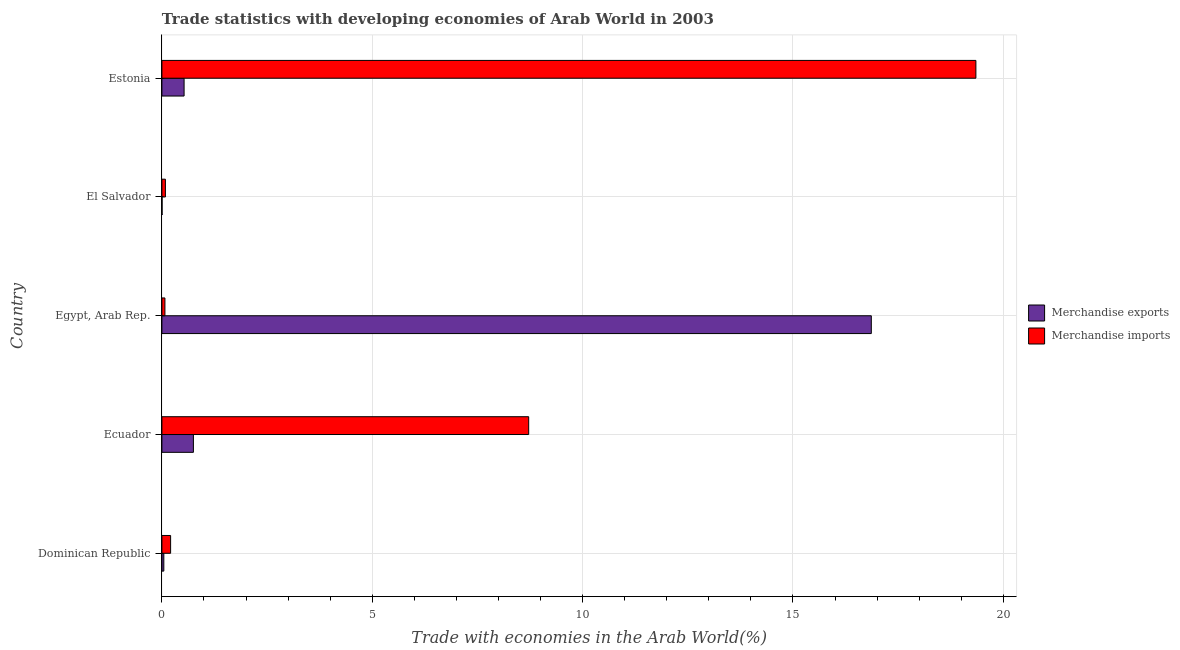How many different coloured bars are there?
Make the answer very short. 2. Are the number of bars per tick equal to the number of legend labels?
Offer a very short reply. Yes. How many bars are there on the 2nd tick from the top?
Provide a succinct answer. 2. What is the label of the 4th group of bars from the top?
Make the answer very short. Ecuador. What is the merchandise imports in El Salvador?
Provide a short and direct response. 0.08. Across all countries, what is the maximum merchandise exports?
Offer a very short reply. 16.86. Across all countries, what is the minimum merchandise exports?
Give a very brief answer. 0. In which country was the merchandise imports maximum?
Offer a terse response. Estonia. In which country was the merchandise exports minimum?
Ensure brevity in your answer.  El Salvador. What is the total merchandise imports in the graph?
Provide a short and direct response. 28.43. What is the difference between the merchandise imports in Dominican Republic and that in Estonia?
Offer a terse response. -19.14. What is the difference between the merchandise exports in Ecuador and the merchandise imports in Egypt, Arab Rep.?
Your response must be concise. 0.68. What is the average merchandise imports per country?
Your answer should be compact. 5.69. What is the difference between the merchandise exports and merchandise imports in Ecuador?
Your response must be concise. -7.97. In how many countries, is the merchandise exports greater than 14 %?
Your answer should be compact. 1. What is the ratio of the merchandise imports in Ecuador to that in Estonia?
Provide a succinct answer. 0.45. Is the merchandise imports in Egypt, Arab Rep. less than that in El Salvador?
Give a very brief answer. Yes. Is the difference between the merchandise exports in Ecuador and El Salvador greater than the difference between the merchandise imports in Ecuador and El Salvador?
Your response must be concise. No. What is the difference between the highest and the second highest merchandise exports?
Keep it short and to the point. 16.11. What is the difference between the highest and the lowest merchandise imports?
Ensure brevity in your answer.  19.28. In how many countries, is the merchandise exports greater than the average merchandise exports taken over all countries?
Provide a short and direct response. 1. Is the sum of the merchandise imports in Dominican Republic and Estonia greater than the maximum merchandise exports across all countries?
Your answer should be compact. Yes. How many bars are there?
Keep it short and to the point. 10. Are all the bars in the graph horizontal?
Keep it short and to the point. Yes. Are the values on the major ticks of X-axis written in scientific E-notation?
Your response must be concise. No. Where does the legend appear in the graph?
Ensure brevity in your answer.  Center right. How are the legend labels stacked?
Offer a very short reply. Vertical. What is the title of the graph?
Provide a short and direct response. Trade statistics with developing economies of Arab World in 2003. Does "RDB concessional" appear as one of the legend labels in the graph?
Ensure brevity in your answer.  No. What is the label or title of the X-axis?
Keep it short and to the point. Trade with economies in the Arab World(%). What is the label or title of the Y-axis?
Offer a terse response. Country. What is the Trade with economies in the Arab World(%) in Merchandise exports in Dominican Republic?
Provide a short and direct response. 0.05. What is the Trade with economies in the Arab World(%) in Merchandise imports in Dominican Republic?
Offer a very short reply. 0.21. What is the Trade with economies in the Arab World(%) of Merchandise exports in Ecuador?
Keep it short and to the point. 0.75. What is the Trade with economies in the Arab World(%) of Merchandise imports in Ecuador?
Provide a short and direct response. 8.72. What is the Trade with economies in the Arab World(%) in Merchandise exports in Egypt, Arab Rep.?
Your answer should be compact. 16.86. What is the Trade with economies in the Arab World(%) in Merchandise imports in Egypt, Arab Rep.?
Your response must be concise. 0.07. What is the Trade with economies in the Arab World(%) of Merchandise exports in El Salvador?
Offer a terse response. 0. What is the Trade with economies in the Arab World(%) in Merchandise imports in El Salvador?
Offer a terse response. 0.08. What is the Trade with economies in the Arab World(%) in Merchandise exports in Estonia?
Offer a terse response. 0.53. What is the Trade with economies in the Arab World(%) of Merchandise imports in Estonia?
Offer a terse response. 19.35. Across all countries, what is the maximum Trade with economies in the Arab World(%) of Merchandise exports?
Make the answer very short. 16.86. Across all countries, what is the maximum Trade with economies in the Arab World(%) of Merchandise imports?
Ensure brevity in your answer.  19.35. Across all countries, what is the minimum Trade with economies in the Arab World(%) of Merchandise exports?
Offer a terse response. 0. Across all countries, what is the minimum Trade with economies in the Arab World(%) of Merchandise imports?
Provide a succinct answer. 0.07. What is the total Trade with economies in the Arab World(%) of Merchandise exports in the graph?
Ensure brevity in your answer.  18.19. What is the total Trade with economies in the Arab World(%) in Merchandise imports in the graph?
Your answer should be compact. 28.43. What is the difference between the Trade with economies in the Arab World(%) of Merchandise exports in Dominican Republic and that in Ecuador?
Offer a terse response. -0.7. What is the difference between the Trade with economies in the Arab World(%) in Merchandise imports in Dominican Republic and that in Ecuador?
Keep it short and to the point. -8.51. What is the difference between the Trade with economies in the Arab World(%) in Merchandise exports in Dominican Republic and that in Egypt, Arab Rep.?
Your answer should be compact. -16.82. What is the difference between the Trade with economies in the Arab World(%) in Merchandise imports in Dominican Republic and that in Egypt, Arab Rep.?
Provide a succinct answer. 0.14. What is the difference between the Trade with economies in the Arab World(%) in Merchandise exports in Dominican Republic and that in El Salvador?
Your response must be concise. 0.04. What is the difference between the Trade with economies in the Arab World(%) in Merchandise imports in Dominican Republic and that in El Salvador?
Your answer should be compact. 0.12. What is the difference between the Trade with economies in the Arab World(%) in Merchandise exports in Dominican Republic and that in Estonia?
Your answer should be very brief. -0.48. What is the difference between the Trade with economies in the Arab World(%) of Merchandise imports in Dominican Republic and that in Estonia?
Provide a short and direct response. -19.14. What is the difference between the Trade with economies in the Arab World(%) in Merchandise exports in Ecuador and that in Egypt, Arab Rep.?
Your response must be concise. -16.11. What is the difference between the Trade with economies in the Arab World(%) of Merchandise imports in Ecuador and that in Egypt, Arab Rep.?
Make the answer very short. 8.65. What is the difference between the Trade with economies in the Arab World(%) of Merchandise exports in Ecuador and that in El Salvador?
Your answer should be very brief. 0.74. What is the difference between the Trade with economies in the Arab World(%) of Merchandise imports in Ecuador and that in El Salvador?
Ensure brevity in your answer.  8.64. What is the difference between the Trade with economies in the Arab World(%) of Merchandise exports in Ecuador and that in Estonia?
Ensure brevity in your answer.  0.22. What is the difference between the Trade with economies in the Arab World(%) in Merchandise imports in Ecuador and that in Estonia?
Offer a terse response. -10.63. What is the difference between the Trade with economies in the Arab World(%) in Merchandise exports in Egypt, Arab Rep. and that in El Salvador?
Make the answer very short. 16.86. What is the difference between the Trade with economies in the Arab World(%) in Merchandise imports in Egypt, Arab Rep. and that in El Salvador?
Give a very brief answer. -0.01. What is the difference between the Trade with economies in the Arab World(%) of Merchandise exports in Egypt, Arab Rep. and that in Estonia?
Provide a short and direct response. 16.34. What is the difference between the Trade with economies in the Arab World(%) of Merchandise imports in Egypt, Arab Rep. and that in Estonia?
Provide a short and direct response. -19.28. What is the difference between the Trade with economies in the Arab World(%) of Merchandise exports in El Salvador and that in Estonia?
Offer a very short reply. -0.52. What is the difference between the Trade with economies in the Arab World(%) of Merchandise imports in El Salvador and that in Estonia?
Your answer should be compact. -19.27. What is the difference between the Trade with economies in the Arab World(%) in Merchandise exports in Dominican Republic and the Trade with economies in the Arab World(%) in Merchandise imports in Ecuador?
Your answer should be compact. -8.67. What is the difference between the Trade with economies in the Arab World(%) of Merchandise exports in Dominican Republic and the Trade with economies in the Arab World(%) of Merchandise imports in Egypt, Arab Rep.?
Your answer should be compact. -0.03. What is the difference between the Trade with economies in the Arab World(%) of Merchandise exports in Dominican Republic and the Trade with economies in the Arab World(%) of Merchandise imports in El Salvador?
Make the answer very short. -0.04. What is the difference between the Trade with economies in the Arab World(%) of Merchandise exports in Dominican Republic and the Trade with economies in the Arab World(%) of Merchandise imports in Estonia?
Make the answer very short. -19.3. What is the difference between the Trade with economies in the Arab World(%) of Merchandise exports in Ecuador and the Trade with economies in the Arab World(%) of Merchandise imports in Egypt, Arab Rep.?
Keep it short and to the point. 0.68. What is the difference between the Trade with economies in the Arab World(%) in Merchandise exports in Ecuador and the Trade with economies in the Arab World(%) in Merchandise imports in El Salvador?
Provide a succinct answer. 0.67. What is the difference between the Trade with economies in the Arab World(%) in Merchandise exports in Ecuador and the Trade with economies in the Arab World(%) in Merchandise imports in Estonia?
Your answer should be very brief. -18.6. What is the difference between the Trade with economies in the Arab World(%) in Merchandise exports in Egypt, Arab Rep. and the Trade with economies in the Arab World(%) in Merchandise imports in El Salvador?
Your answer should be very brief. 16.78. What is the difference between the Trade with economies in the Arab World(%) in Merchandise exports in Egypt, Arab Rep. and the Trade with economies in the Arab World(%) in Merchandise imports in Estonia?
Ensure brevity in your answer.  -2.49. What is the difference between the Trade with economies in the Arab World(%) in Merchandise exports in El Salvador and the Trade with economies in the Arab World(%) in Merchandise imports in Estonia?
Give a very brief answer. -19.34. What is the average Trade with economies in the Arab World(%) of Merchandise exports per country?
Ensure brevity in your answer.  3.64. What is the average Trade with economies in the Arab World(%) of Merchandise imports per country?
Provide a short and direct response. 5.69. What is the difference between the Trade with economies in the Arab World(%) in Merchandise exports and Trade with economies in the Arab World(%) in Merchandise imports in Dominican Republic?
Give a very brief answer. -0.16. What is the difference between the Trade with economies in the Arab World(%) of Merchandise exports and Trade with economies in the Arab World(%) of Merchandise imports in Ecuador?
Your answer should be compact. -7.97. What is the difference between the Trade with economies in the Arab World(%) of Merchandise exports and Trade with economies in the Arab World(%) of Merchandise imports in Egypt, Arab Rep.?
Your response must be concise. 16.79. What is the difference between the Trade with economies in the Arab World(%) of Merchandise exports and Trade with economies in the Arab World(%) of Merchandise imports in El Salvador?
Provide a short and direct response. -0.08. What is the difference between the Trade with economies in the Arab World(%) in Merchandise exports and Trade with economies in the Arab World(%) in Merchandise imports in Estonia?
Provide a short and direct response. -18.82. What is the ratio of the Trade with economies in the Arab World(%) of Merchandise exports in Dominican Republic to that in Ecuador?
Offer a terse response. 0.06. What is the ratio of the Trade with economies in the Arab World(%) in Merchandise imports in Dominican Republic to that in Ecuador?
Your response must be concise. 0.02. What is the ratio of the Trade with economies in the Arab World(%) in Merchandise exports in Dominican Republic to that in Egypt, Arab Rep.?
Your answer should be very brief. 0. What is the ratio of the Trade with economies in the Arab World(%) in Merchandise imports in Dominican Republic to that in Egypt, Arab Rep.?
Make the answer very short. 2.89. What is the ratio of the Trade with economies in the Arab World(%) of Merchandise exports in Dominican Republic to that in El Salvador?
Offer a terse response. 12.49. What is the ratio of the Trade with economies in the Arab World(%) in Merchandise imports in Dominican Republic to that in El Salvador?
Ensure brevity in your answer.  2.49. What is the ratio of the Trade with economies in the Arab World(%) in Merchandise exports in Dominican Republic to that in Estonia?
Your response must be concise. 0.09. What is the ratio of the Trade with economies in the Arab World(%) in Merchandise imports in Dominican Republic to that in Estonia?
Your response must be concise. 0.01. What is the ratio of the Trade with economies in the Arab World(%) of Merchandise exports in Ecuador to that in Egypt, Arab Rep.?
Your response must be concise. 0.04. What is the ratio of the Trade with economies in the Arab World(%) in Merchandise imports in Ecuador to that in Egypt, Arab Rep.?
Your response must be concise. 121.68. What is the ratio of the Trade with economies in the Arab World(%) in Merchandise exports in Ecuador to that in El Salvador?
Provide a succinct answer. 204.11. What is the ratio of the Trade with economies in the Arab World(%) in Merchandise imports in Ecuador to that in El Salvador?
Make the answer very short. 104.76. What is the ratio of the Trade with economies in the Arab World(%) of Merchandise exports in Ecuador to that in Estonia?
Provide a short and direct response. 1.42. What is the ratio of the Trade with economies in the Arab World(%) in Merchandise imports in Ecuador to that in Estonia?
Give a very brief answer. 0.45. What is the ratio of the Trade with economies in the Arab World(%) of Merchandise exports in Egypt, Arab Rep. to that in El Salvador?
Keep it short and to the point. 4596.99. What is the ratio of the Trade with economies in the Arab World(%) of Merchandise imports in Egypt, Arab Rep. to that in El Salvador?
Your answer should be very brief. 0.86. What is the ratio of the Trade with economies in the Arab World(%) of Merchandise exports in Egypt, Arab Rep. to that in Estonia?
Offer a terse response. 31.98. What is the ratio of the Trade with economies in the Arab World(%) in Merchandise imports in Egypt, Arab Rep. to that in Estonia?
Provide a short and direct response. 0. What is the ratio of the Trade with economies in the Arab World(%) of Merchandise exports in El Salvador to that in Estonia?
Ensure brevity in your answer.  0.01. What is the ratio of the Trade with economies in the Arab World(%) in Merchandise imports in El Salvador to that in Estonia?
Your response must be concise. 0. What is the difference between the highest and the second highest Trade with economies in the Arab World(%) of Merchandise exports?
Your answer should be very brief. 16.11. What is the difference between the highest and the second highest Trade with economies in the Arab World(%) in Merchandise imports?
Your answer should be compact. 10.63. What is the difference between the highest and the lowest Trade with economies in the Arab World(%) of Merchandise exports?
Ensure brevity in your answer.  16.86. What is the difference between the highest and the lowest Trade with economies in the Arab World(%) of Merchandise imports?
Provide a succinct answer. 19.28. 